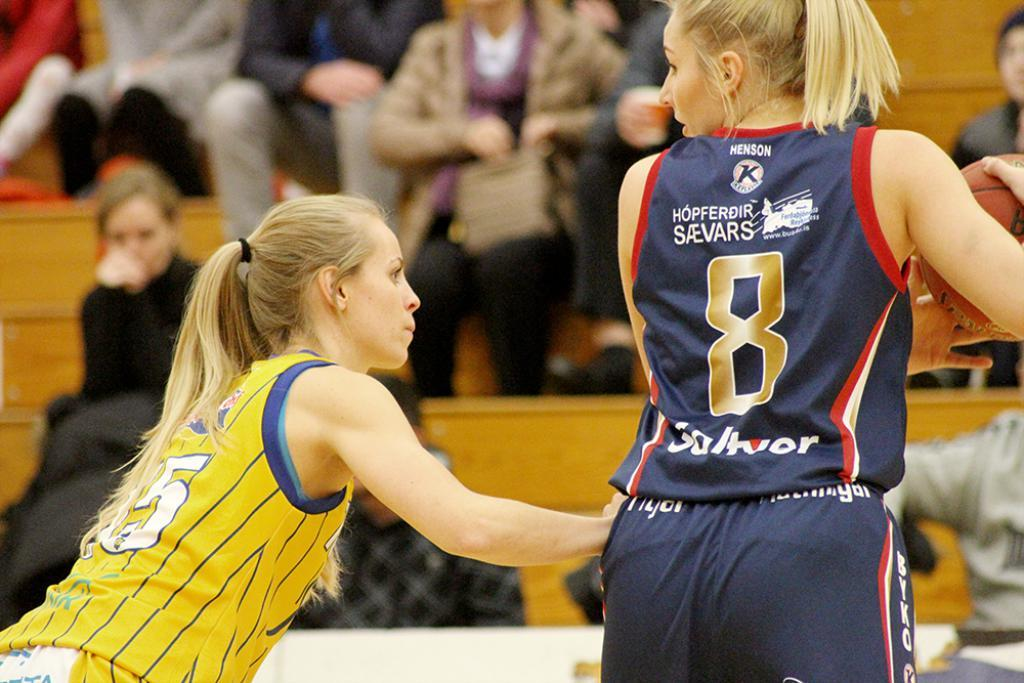<image>
Write a terse but informative summary of the picture. the number 8 is on the back of the jersey 